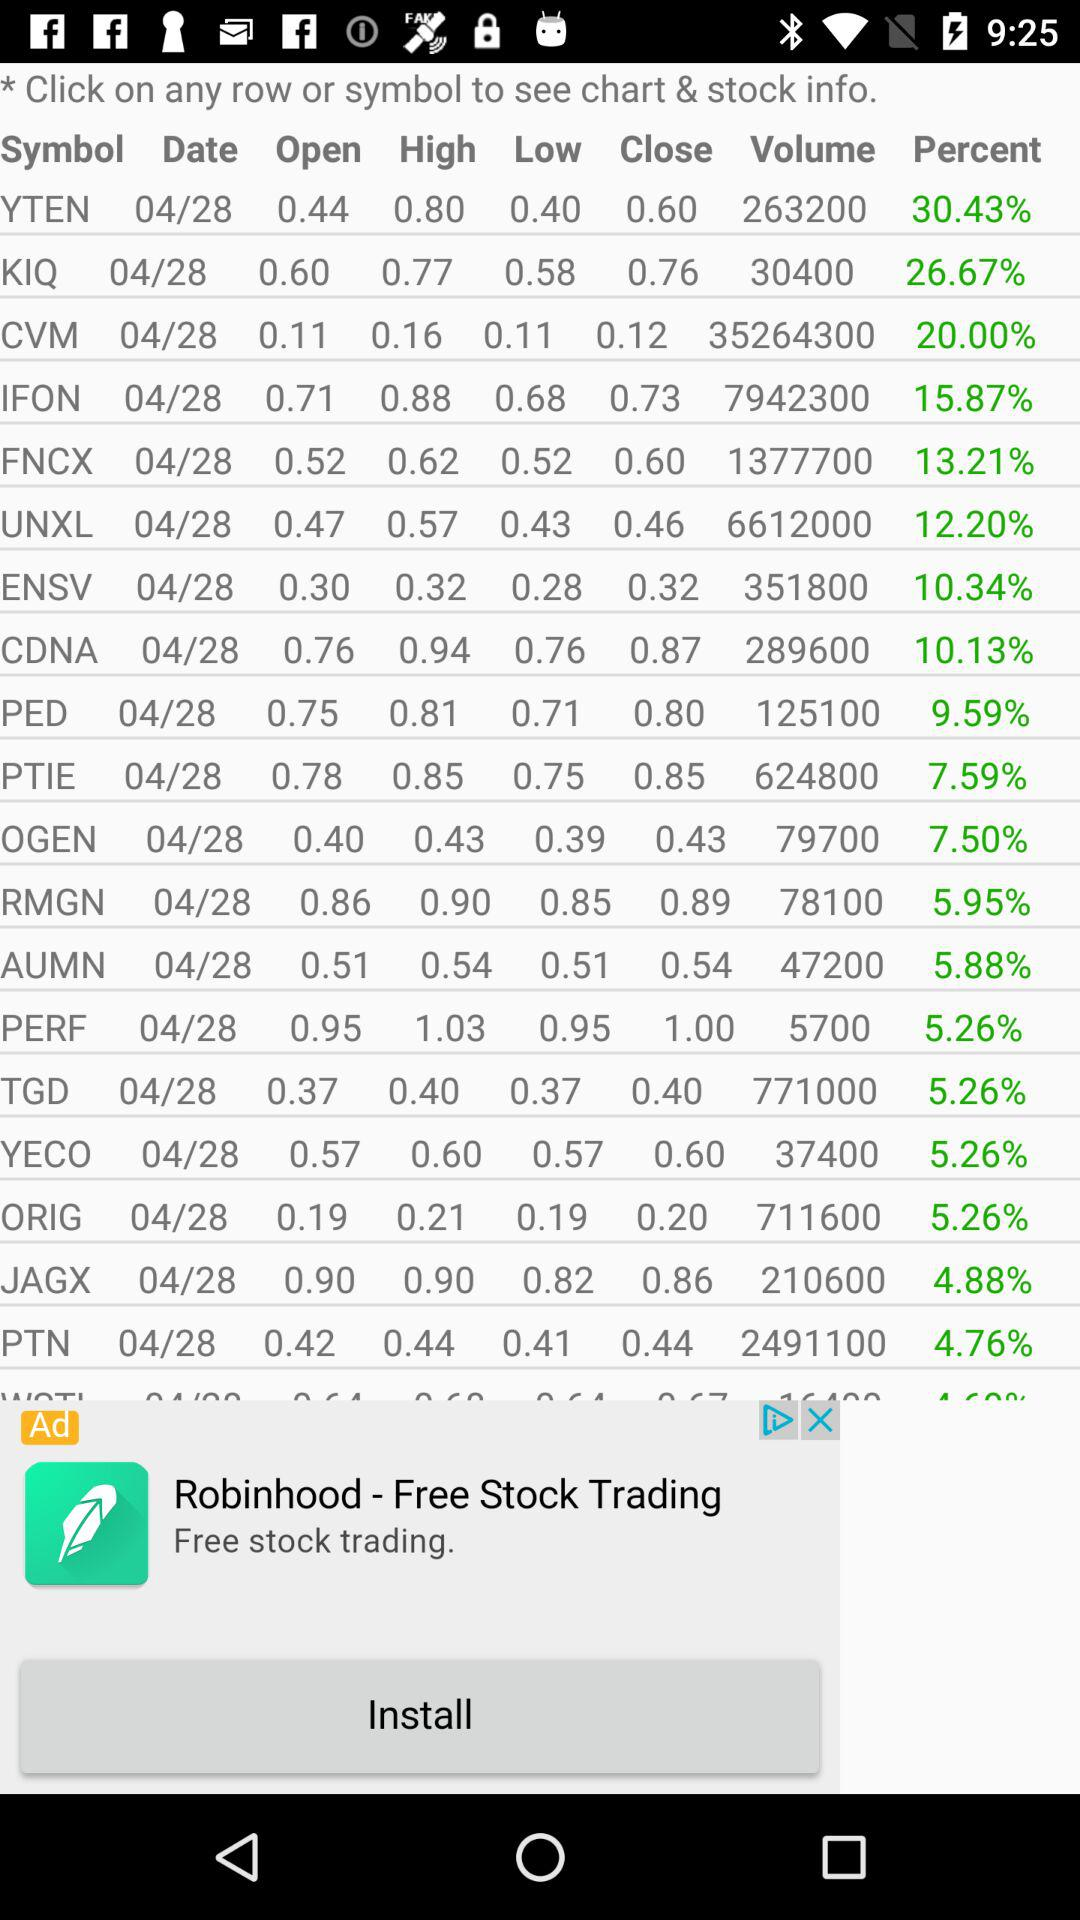What is the percent of "KIQ"? The percent of "KIQ" is 26.67. 